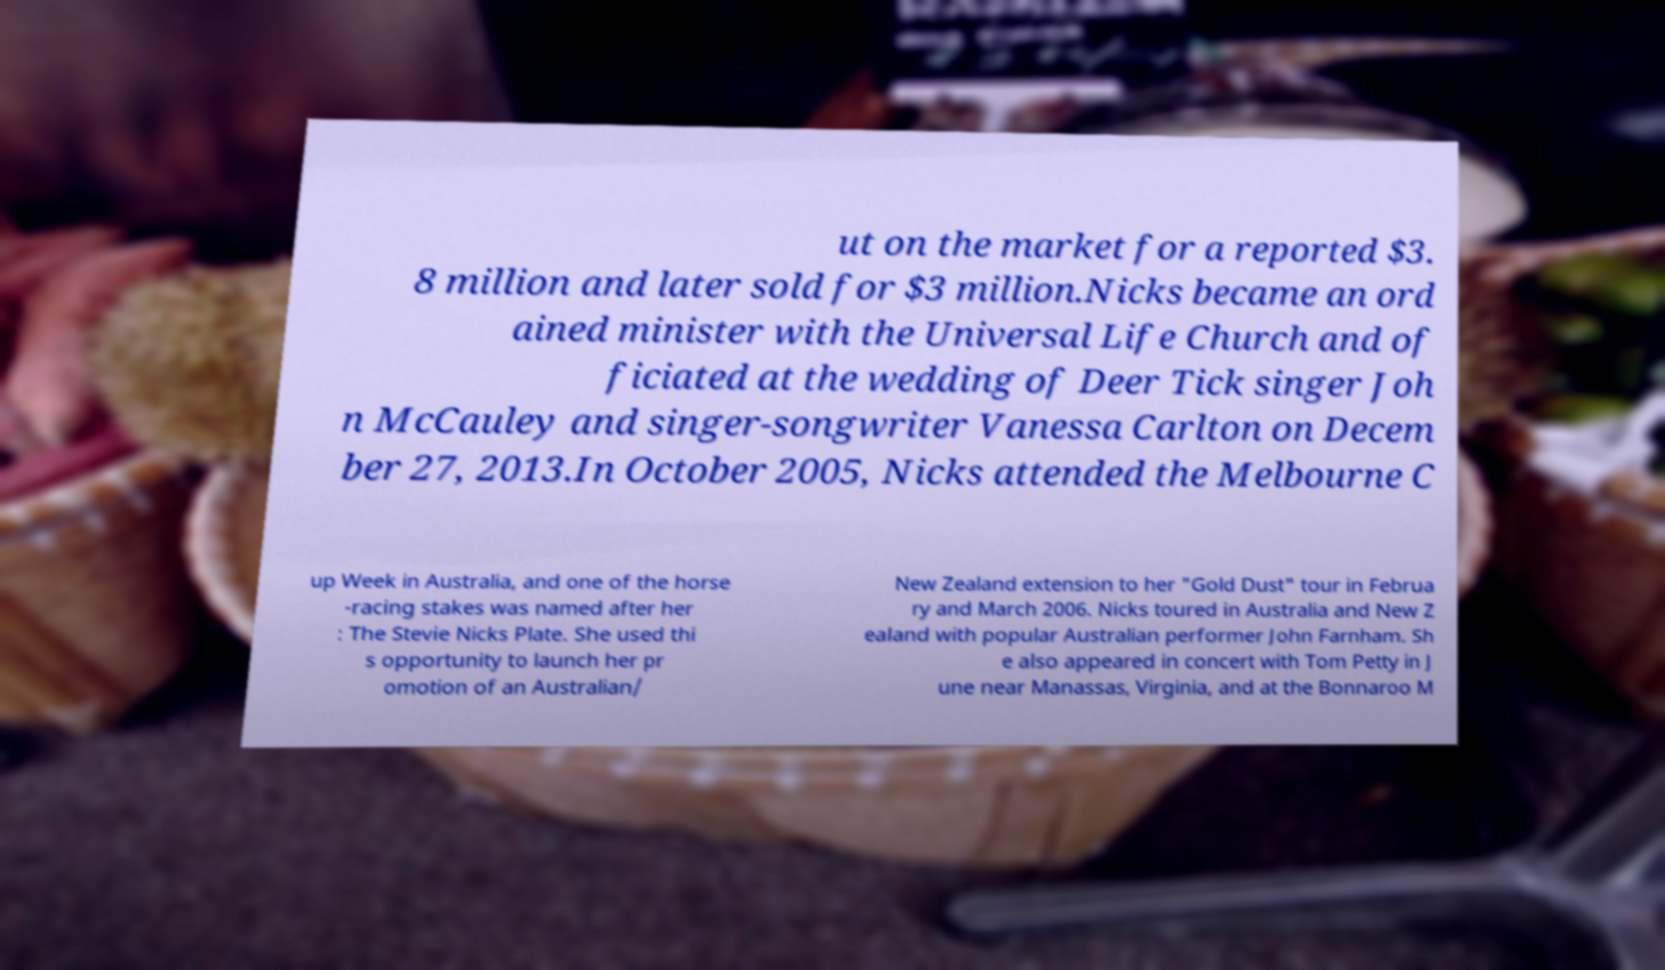Please read and relay the text visible in this image. What does it say? ut on the market for a reported $3. 8 million and later sold for $3 million.Nicks became an ord ained minister with the Universal Life Church and of ficiated at the wedding of Deer Tick singer Joh n McCauley and singer-songwriter Vanessa Carlton on Decem ber 27, 2013.In October 2005, Nicks attended the Melbourne C up Week in Australia, and one of the horse -racing stakes was named after her : The Stevie Nicks Plate. She used thi s opportunity to launch her pr omotion of an Australian/ New Zealand extension to her "Gold Dust" tour in Februa ry and March 2006. Nicks toured in Australia and New Z ealand with popular Australian performer John Farnham. Sh e also appeared in concert with Tom Petty in J une near Manassas, Virginia, and at the Bonnaroo M 